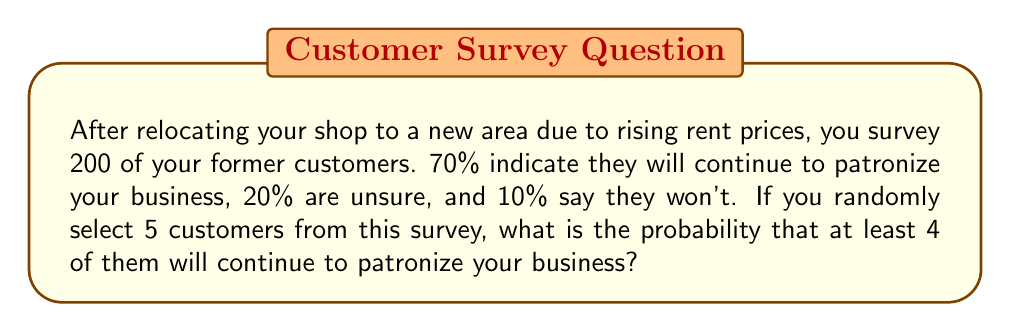What is the answer to this math problem? Let's approach this step-by-step:

1) First, we need to identify the probability of a customer continuing to patronize the business. This is given as 70% or 0.7.

2) We're looking for the probability of at least 4 out of 5 customers continuing to patronize. This means we need to calculate the probability of exactly 4 out of 5, plus the probability of 5 out of 5.

3) This scenario follows a binomial distribution. The probability mass function for a binomial distribution is:

   $$P(X = k) = \binom{n}{k} p^k (1-p)^{n-k}$$

   Where:
   $n$ = number of trials (5 in this case)
   $k$ = number of successes
   $p$ = probability of success on each trial (0.7 in this case)

4) For 4 out of 5:
   $$P(X = 4) = \binom{5}{4} (0.7)^4 (0.3)^1 = 5 \times 0.2401 \times 0.3 = 0.36015$$

5) For 5 out of 5:
   $$P(X = 5) = \binom{5}{5} (0.7)^5 (0.3)^0 = 1 \times 0.16807 \times 1 = 0.16807$$

6) The probability of at least 4 out of 5 is the sum of these two probabilities:

   $$P(X \geq 4) = P(X = 4) + P(X = 5) = 0.36015 + 0.16807 = 0.52822$$
Answer: 0.52822 